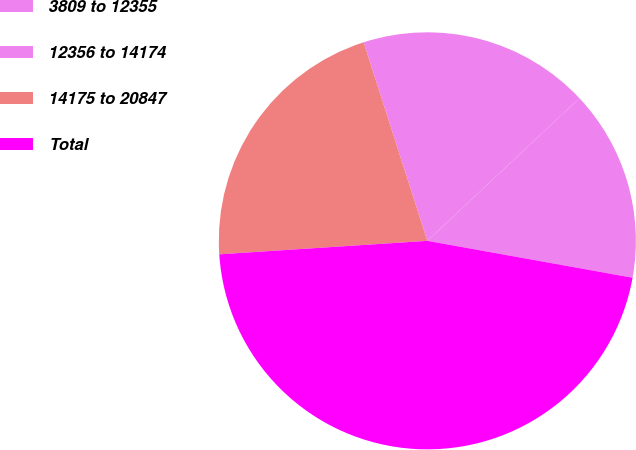Convert chart. <chart><loc_0><loc_0><loc_500><loc_500><pie_chart><fcel>3809 to 12355<fcel>12356 to 14174<fcel>14175 to 20847<fcel>Total<nl><fcel>14.82%<fcel>17.95%<fcel>21.09%<fcel>46.14%<nl></chart> 